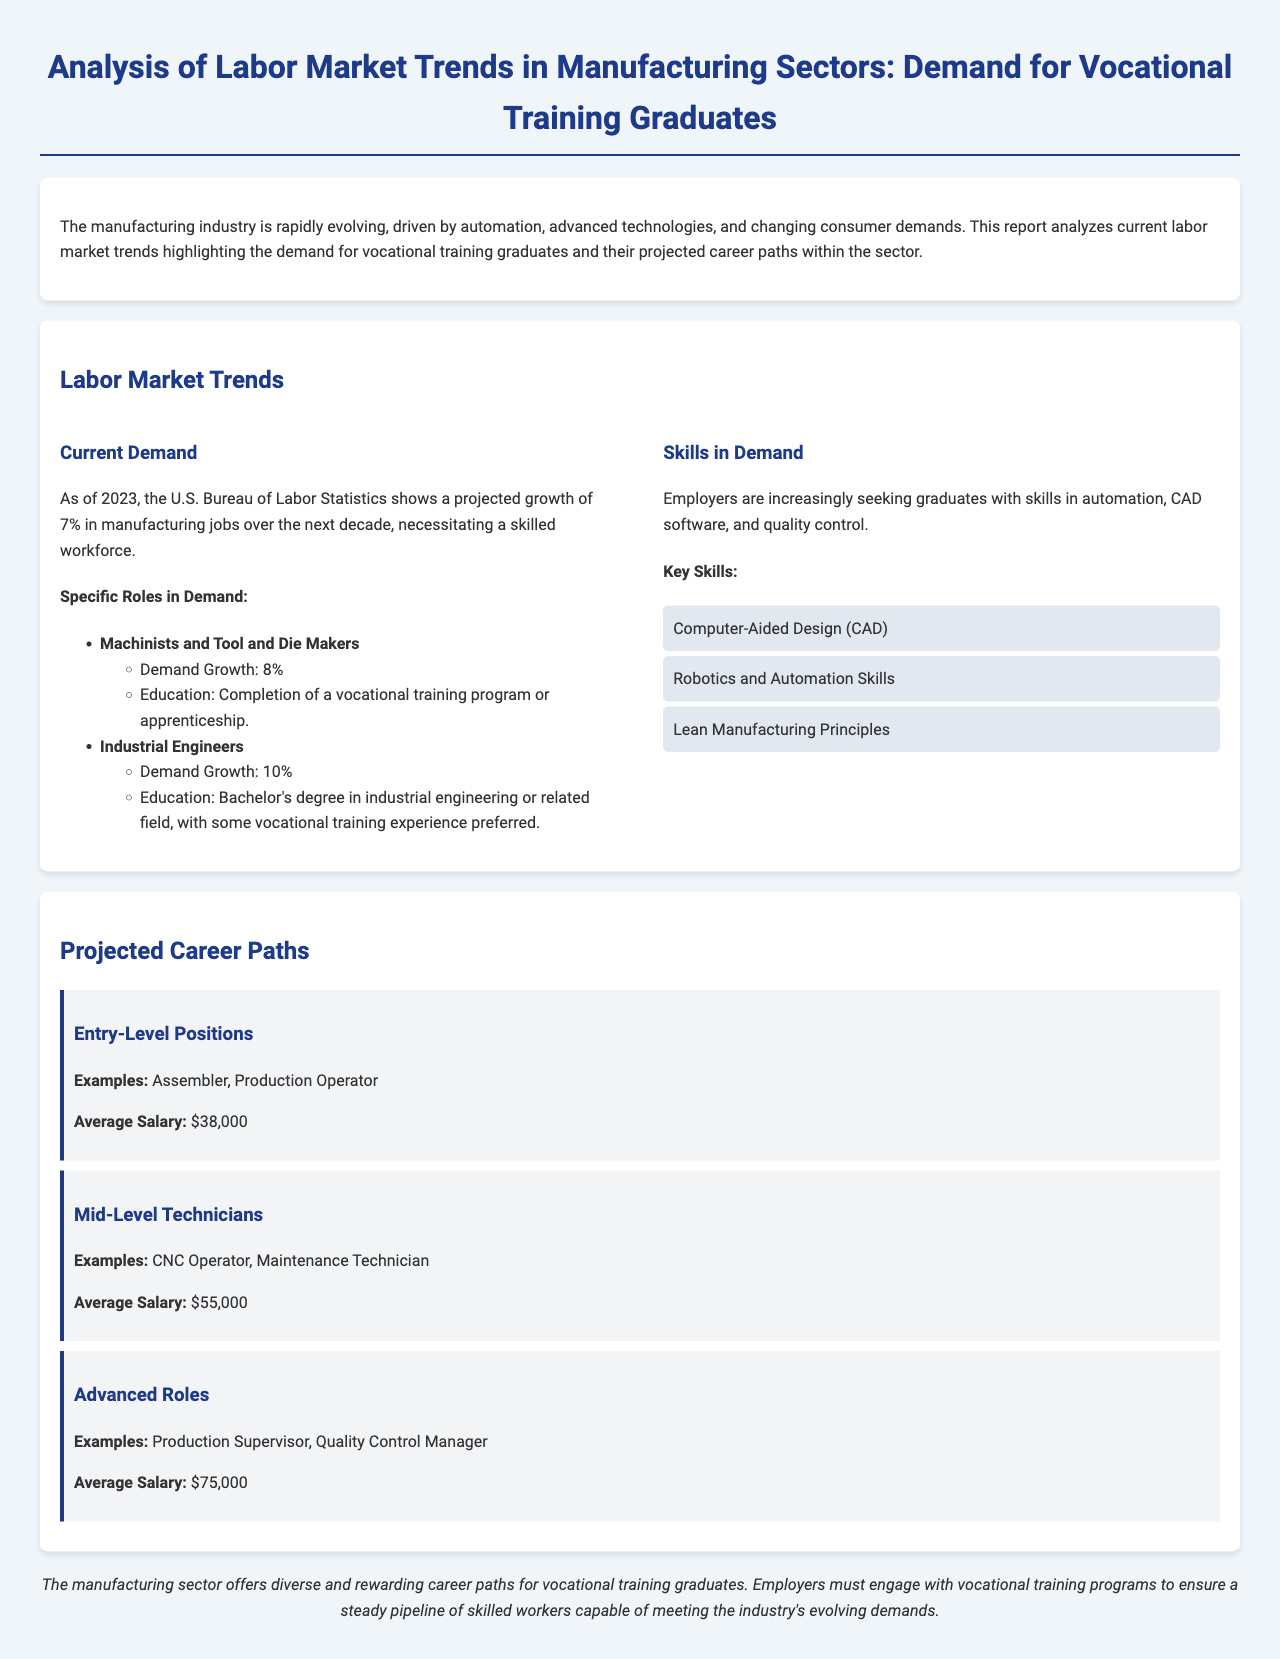what is the projected growth rate for manufacturing jobs? The projected growth rate for manufacturing jobs over the next decade is stated as 7%.
Answer: 7% which role has the highest demand growth percentage? Among the listed roles, Industrial Engineers have the highest demand growth of 10%.
Answer: Industrial Engineers what is the average salary for Entry-Level Positions? The document provides the average salary for Entry-Level Positions as $38,000.
Answer: $38,000 name a key skill sought by employers in the manufacturing sector. The document lists Computer-Aided Design (CAD) as a key skill in demand.
Answer: Computer-Aided Design (CAD) what is the minimum educational requirement for Machinists and Tool and Die Makers? The educational requirement for Machinists and Tool and Die Makers is the completion of a vocational training program or apprenticeship.
Answer: Completion of a vocational training program which career path is associated with an average salary of $55,000? The Mid-Level Technicians career path is associated with the average salary of $55,000.
Answer: Mid-Level Technicians how many specific roles in demand are listed in the document? The document lists two specific roles in demand, which are Machinists and Tool and Die Makers, and Industrial Engineers.
Answer: Two what is one of the advanced roles mentioned in the report? One of the advanced roles mentioned in the report is Production Supervisor.
Answer: Production Supervisor what is the average salary for Advanced Roles? The average salary for Advanced Roles is stated as $75,000.
Answer: $75,000 